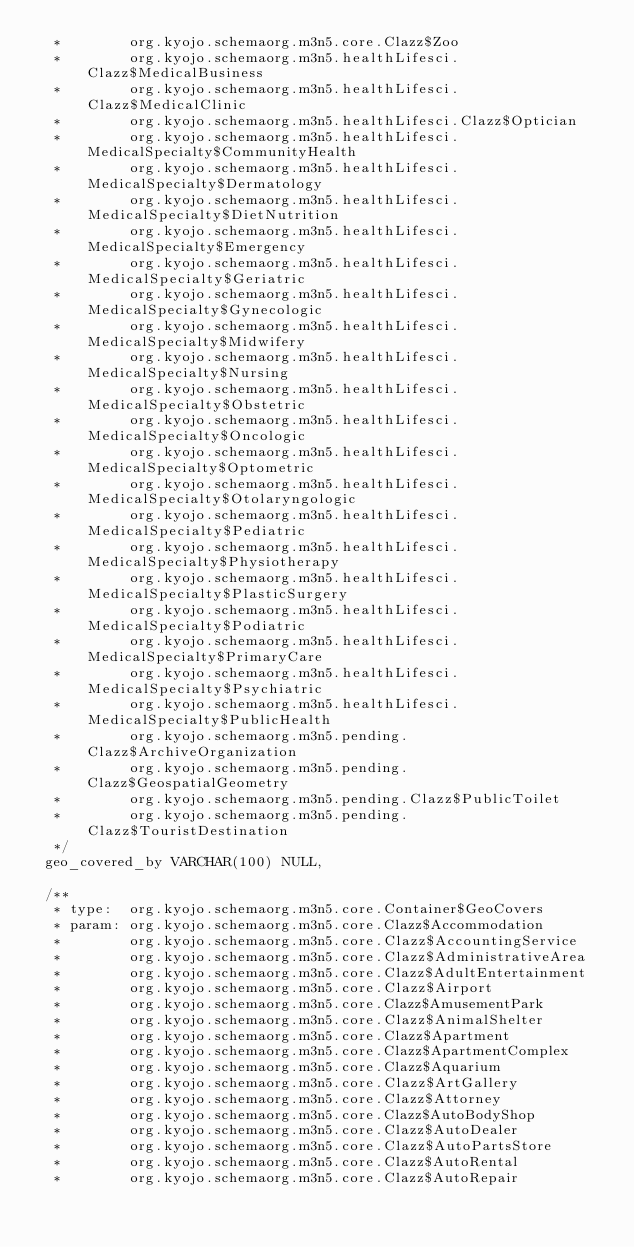Convert code to text. <code><loc_0><loc_0><loc_500><loc_500><_SQL_>  *        org.kyojo.schemaorg.m3n5.core.Clazz$Zoo
  *        org.kyojo.schemaorg.m3n5.healthLifesci.Clazz$MedicalBusiness
  *        org.kyojo.schemaorg.m3n5.healthLifesci.Clazz$MedicalClinic
  *        org.kyojo.schemaorg.m3n5.healthLifesci.Clazz$Optician
  *        org.kyojo.schemaorg.m3n5.healthLifesci.MedicalSpecialty$CommunityHealth
  *        org.kyojo.schemaorg.m3n5.healthLifesci.MedicalSpecialty$Dermatology
  *        org.kyojo.schemaorg.m3n5.healthLifesci.MedicalSpecialty$DietNutrition
  *        org.kyojo.schemaorg.m3n5.healthLifesci.MedicalSpecialty$Emergency
  *        org.kyojo.schemaorg.m3n5.healthLifesci.MedicalSpecialty$Geriatric
  *        org.kyojo.schemaorg.m3n5.healthLifesci.MedicalSpecialty$Gynecologic
  *        org.kyojo.schemaorg.m3n5.healthLifesci.MedicalSpecialty$Midwifery
  *        org.kyojo.schemaorg.m3n5.healthLifesci.MedicalSpecialty$Nursing
  *        org.kyojo.schemaorg.m3n5.healthLifesci.MedicalSpecialty$Obstetric
  *        org.kyojo.schemaorg.m3n5.healthLifesci.MedicalSpecialty$Oncologic
  *        org.kyojo.schemaorg.m3n5.healthLifesci.MedicalSpecialty$Optometric
  *        org.kyojo.schemaorg.m3n5.healthLifesci.MedicalSpecialty$Otolaryngologic
  *        org.kyojo.schemaorg.m3n5.healthLifesci.MedicalSpecialty$Pediatric
  *        org.kyojo.schemaorg.m3n5.healthLifesci.MedicalSpecialty$Physiotherapy
  *        org.kyojo.schemaorg.m3n5.healthLifesci.MedicalSpecialty$PlasticSurgery
  *        org.kyojo.schemaorg.m3n5.healthLifesci.MedicalSpecialty$Podiatric
  *        org.kyojo.schemaorg.m3n5.healthLifesci.MedicalSpecialty$PrimaryCare
  *        org.kyojo.schemaorg.m3n5.healthLifesci.MedicalSpecialty$Psychiatric
  *        org.kyojo.schemaorg.m3n5.healthLifesci.MedicalSpecialty$PublicHealth
  *        org.kyojo.schemaorg.m3n5.pending.Clazz$ArchiveOrganization
  *        org.kyojo.schemaorg.m3n5.pending.Clazz$GeospatialGeometry
  *        org.kyojo.schemaorg.m3n5.pending.Clazz$PublicToilet
  *        org.kyojo.schemaorg.m3n5.pending.Clazz$TouristDestination
  */
 geo_covered_by VARCHAR(100) NULL,

 /**
  * type:  org.kyojo.schemaorg.m3n5.core.Container$GeoCovers
  * param: org.kyojo.schemaorg.m3n5.core.Clazz$Accommodation
  *        org.kyojo.schemaorg.m3n5.core.Clazz$AccountingService
  *        org.kyojo.schemaorg.m3n5.core.Clazz$AdministrativeArea
  *        org.kyojo.schemaorg.m3n5.core.Clazz$AdultEntertainment
  *        org.kyojo.schemaorg.m3n5.core.Clazz$Airport
  *        org.kyojo.schemaorg.m3n5.core.Clazz$AmusementPark
  *        org.kyojo.schemaorg.m3n5.core.Clazz$AnimalShelter
  *        org.kyojo.schemaorg.m3n5.core.Clazz$Apartment
  *        org.kyojo.schemaorg.m3n5.core.Clazz$ApartmentComplex
  *        org.kyojo.schemaorg.m3n5.core.Clazz$Aquarium
  *        org.kyojo.schemaorg.m3n5.core.Clazz$ArtGallery
  *        org.kyojo.schemaorg.m3n5.core.Clazz$Attorney
  *        org.kyojo.schemaorg.m3n5.core.Clazz$AutoBodyShop
  *        org.kyojo.schemaorg.m3n5.core.Clazz$AutoDealer
  *        org.kyojo.schemaorg.m3n5.core.Clazz$AutoPartsStore
  *        org.kyojo.schemaorg.m3n5.core.Clazz$AutoRental
  *        org.kyojo.schemaorg.m3n5.core.Clazz$AutoRepair</code> 